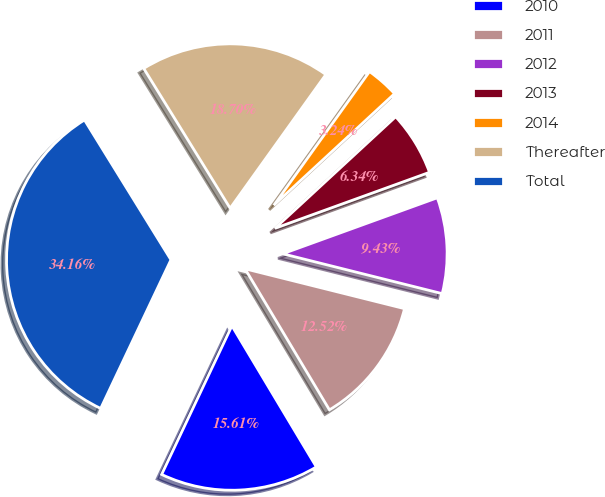<chart> <loc_0><loc_0><loc_500><loc_500><pie_chart><fcel>2010<fcel>2011<fcel>2012<fcel>2013<fcel>2014<fcel>Thereafter<fcel>Total<nl><fcel>15.61%<fcel>12.52%<fcel>9.43%<fcel>6.34%<fcel>3.24%<fcel>18.7%<fcel>34.16%<nl></chart> 